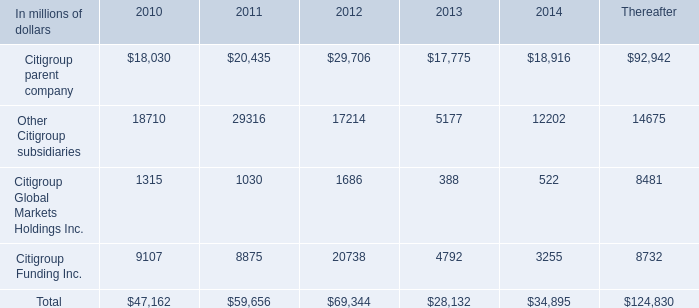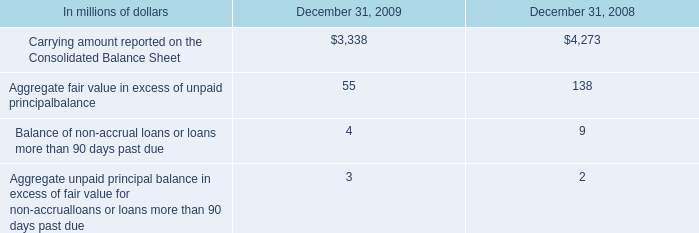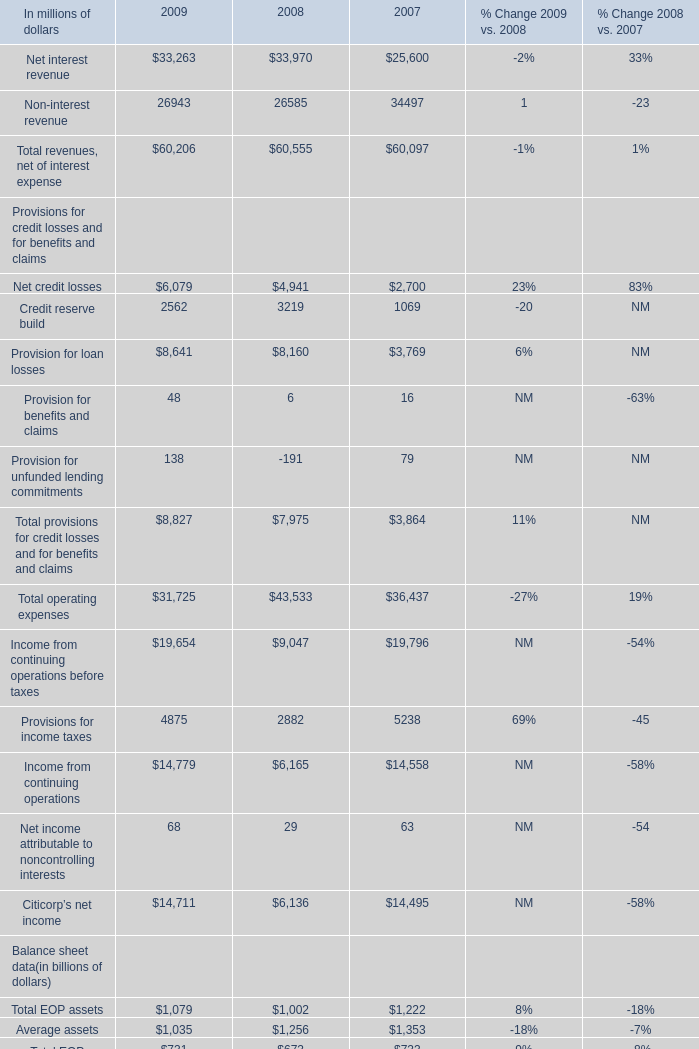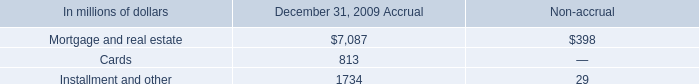what was the percentage decline in aggregate fair value in excess of unpaid principal balance for the loans accounted for with the fair value option from 2008 to 2009 
Computations: ((55 - 138) / 138)
Answer: -0.60145. 